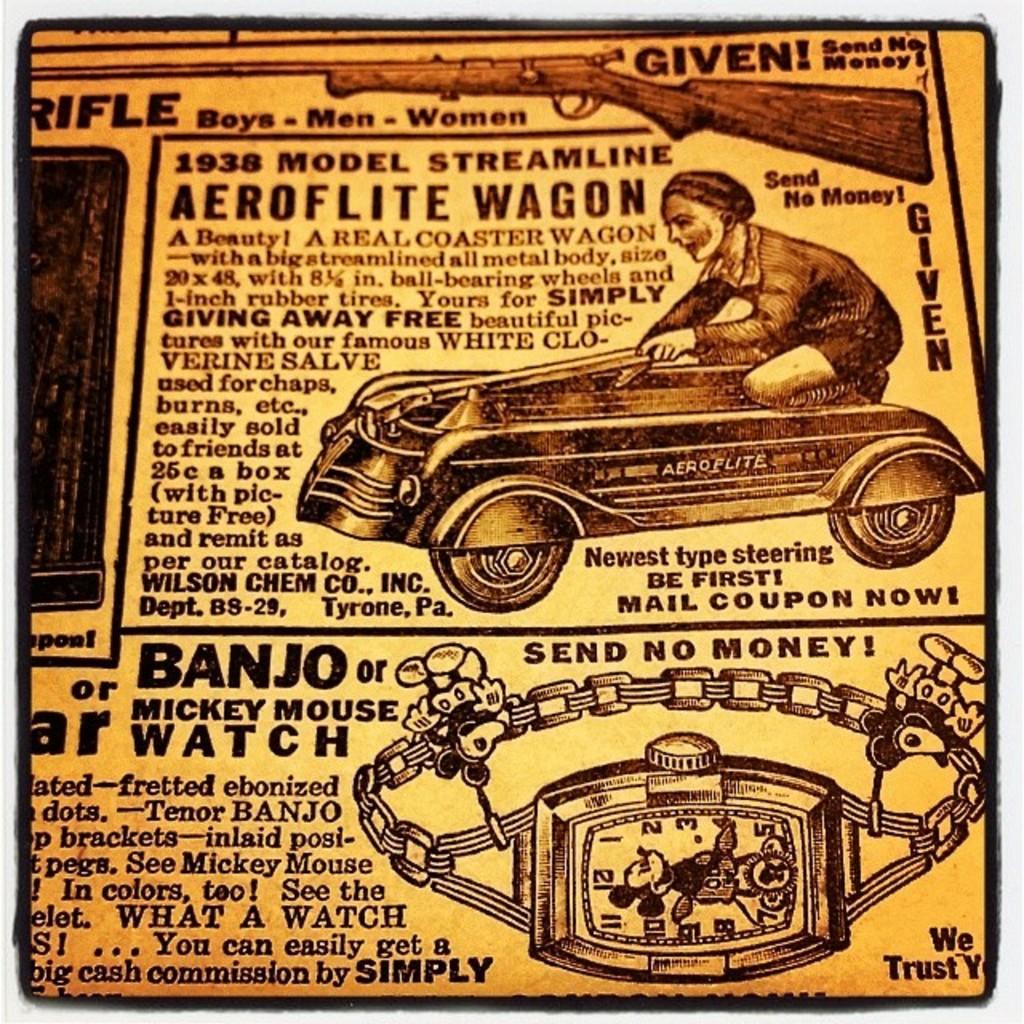In one or two sentences, can you explain what this image depicts? In this image I can see a yellow colour thing and on it I can see something is written. I can also see depiction of a person, a watch and of a gun. 